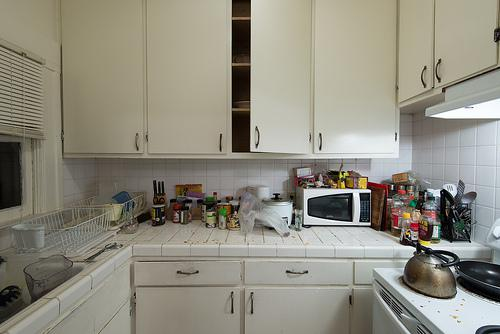Question: where is this picture taken?
Choices:
A. Kitchen.
B. Bathroom.
C. Closet.
D. Basement.
Answer with the letter. Answer: A Question: how many drawers are pictured?
Choices:
A. 9.
B. 2.
C. 8.
D. 7.
Answer with the letter. Answer: B Question: what is in the frying pan?
Choices:
A. Oil.
B. Nothing.
C. Meat.
D. Vegetables.
Answer with the letter. Answer: B Question: how many lights are on?
Choices:
A. 3.
B. 4.
C. 5.
D. 1.
Answer with the letter. Answer: D 